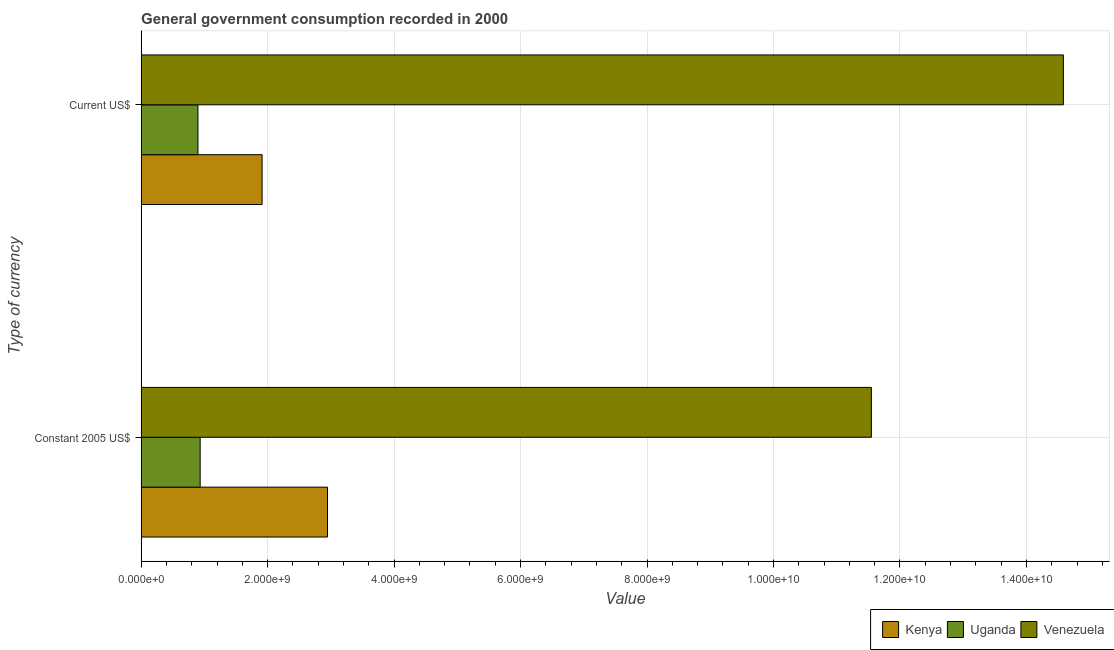How many different coloured bars are there?
Ensure brevity in your answer.  3. How many groups of bars are there?
Provide a succinct answer. 2. Are the number of bars per tick equal to the number of legend labels?
Provide a short and direct response. Yes. Are the number of bars on each tick of the Y-axis equal?
Your answer should be compact. Yes. How many bars are there on the 1st tick from the top?
Make the answer very short. 3. What is the label of the 1st group of bars from the top?
Your answer should be very brief. Current US$. What is the value consumed in current us$ in Uganda?
Your answer should be very brief. 8.98e+08. Across all countries, what is the maximum value consumed in current us$?
Keep it short and to the point. 1.46e+1. Across all countries, what is the minimum value consumed in current us$?
Provide a short and direct response. 8.98e+08. In which country was the value consumed in constant 2005 us$ maximum?
Provide a short and direct response. Venezuela. In which country was the value consumed in current us$ minimum?
Your answer should be compact. Uganda. What is the total value consumed in current us$ in the graph?
Provide a short and direct response. 1.74e+1. What is the difference between the value consumed in current us$ in Venezuela and that in Kenya?
Give a very brief answer. 1.27e+1. What is the difference between the value consumed in current us$ in Kenya and the value consumed in constant 2005 us$ in Venezuela?
Keep it short and to the point. -9.64e+09. What is the average value consumed in constant 2005 us$ per country?
Your response must be concise. 5.14e+09. What is the difference between the value consumed in constant 2005 us$ and value consumed in current us$ in Kenya?
Provide a short and direct response. 1.03e+09. In how many countries, is the value consumed in constant 2005 us$ greater than 3600000000 ?
Offer a very short reply. 1. What is the ratio of the value consumed in current us$ in Venezuela to that in Uganda?
Ensure brevity in your answer.  16.24. What does the 3rd bar from the top in Constant 2005 US$ represents?
Offer a terse response. Kenya. What does the 2nd bar from the bottom in Constant 2005 US$ represents?
Provide a succinct answer. Uganda. How many bars are there?
Make the answer very short. 6. Are all the bars in the graph horizontal?
Offer a very short reply. Yes. How many countries are there in the graph?
Your answer should be very brief. 3. What is the difference between two consecutive major ticks on the X-axis?
Provide a succinct answer. 2.00e+09. How are the legend labels stacked?
Your response must be concise. Horizontal. What is the title of the graph?
Offer a very short reply. General government consumption recorded in 2000. Does "Burkina Faso" appear as one of the legend labels in the graph?
Your response must be concise. No. What is the label or title of the X-axis?
Ensure brevity in your answer.  Value. What is the label or title of the Y-axis?
Provide a short and direct response. Type of currency. What is the Value of Kenya in Constant 2005 US$?
Offer a terse response. 2.95e+09. What is the Value of Uganda in Constant 2005 US$?
Your answer should be compact. 9.33e+08. What is the Value in Venezuela in Constant 2005 US$?
Ensure brevity in your answer.  1.15e+1. What is the Value of Kenya in Current US$?
Offer a very short reply. 1.91e+09. What is the Value in Uganda in Current US$?
Ensure brevity in your answer.  8.98e+08. What is the Value in Venezuela in Current US$?
Keep it short and to the point. 1.46e+1. Across all Type of currency, what is the maximum Value in Kenya?
Provide a succinct answer. 2.95e+09. Across all Type of currency, what is the maximum Value of Uganda?
Your response must be concise. 9.33e+08. Across all Type of currency, what is the maximum Value of Venezuela?
Provide a short and direct response. 1.46e+1. Across all Type of currency, what is the minimum Value in Kenya?
Give a very brief answer. 1.91e+09. Across all Type of currency, what is the minimum Value in Uganda?
Offer a terse response. 8.98e+08. Across all Type of currency, what is the minimum Value of Venezuela?
Offer a terse response. 1.15e+1. What is the total Value of Kenya in the graph?
Keep it short and to the point. 4.86e+09. What is the total Value of Uganda in the graph?
Your answer should be compact. 1.83e+09. What is the total Value of Venezuela in the graph?
Make the answer very short. 2.61e+1. What is the difference between the Value in Kenya in Constant 2005 US$ and that in Current US$?
Provide a short and direct response. 1.03e+09. What is the difference between the Value of Uganda in Constant 2005 US$ and that in Current US$?
Offer a terse response. 3.49e+07. What is the difference between the Value of Venezuela in Constant 2005 US$ and that in Current US$?
Provide a succinct answer. -3.04e+09. What is the difference between the Value of Kenya in Constant 2005 US$ and the Value of Uganda in Current US$?
Keep it short and to the point. 2.05e+09. What is the difference between the Value in Kenya in Constant 2005 US$ and the Value in Venezuela in Current US$?
Ensure brevity in your answer.  -1.16e+1. What is the difference between the Value of Uganda in Constant 2005 US$ and the Value of Venezuela in Current US$?
Make the answer very short. -1.37e+1. What is the average Value of Kenya per Type of currency?
Make the answer very short. 2.43e+09. What is the average Value of Uganda per Type of currency?
Keep it short and to the point. 9.16e+08. What is the average Value in Venezuela per Type of currency?
Give a very brief answer. 1.31e+1. What is the difference between the Value in Kenya and Value in Uganda in Constant 2005 US$?
Make the answer very short. 2.01e+09. What is the difference between the Value of Kenya and Value of Venezuela in Constant 2005 US$?
Your response must be concise. -8.60e+09. What is the difference between the Value in Uganda and Value in Venezuela in Constant 2005 US$?
Your answer should be very brief. -1.06e+1. What is the difference between the Value in Kenya and Value in Uganda in Current US$?
Offer a very short reply. 1.01e+09. What is the difference between the Value of Kenya and Value of Venezuela in Current US$?
Your response must be concise. -1.27e+1. What is the difference between the Value in Uganda and Value in Venezuela in Current US$?
Keep it short and to the point. -1.37e+1. What is the ratio of the Value of Kenya in Constant 2005 US$ to that in Current US$?
Make the answer very short. 1.54. What is the ratio of the Value in Uganda in Constant 2005 US$ to that in Current US$?
Give a very brief answer. 1.04. What is the ratio of the Value of Venezuela in Constant 2005 US$ to that in Current US$?
Your answer should be very brief. 0.79. What is the difference between the highest and the second highest Value of Kenya?
Provide a short and direct response. 1.03e+09. What is the difference between the highest and the second highest Value of Uganda?
Provide a short and direct response. 3.49e+07. What is the difference between the highest and the second highest Value in Venezuela?
Your answer should be compact. 3.04e+09. What is the difference between the highest and the lowest Value in Kenya?
Your response must be concise. 1.03e+09. What is the difference between the highest and the lowest Value of Uganda?
Keep it short and to the point. 3.49e+07. What is the difference between the highest and the lowest Value of Venezuela?
Provide a short and direct response. 3.04e+09. 